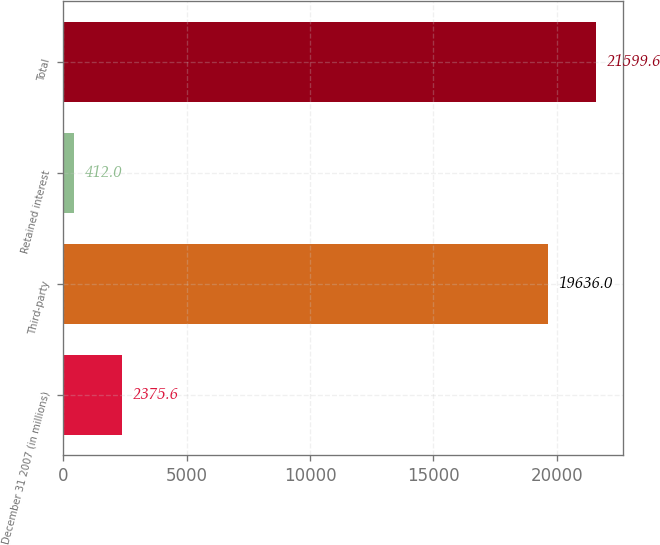Convert chart. <chart><loc_0><loc_0><loc_500><loc_500><bar_chart><fcel>December 31 2007 (in millions)<fcel>Third-party<fcel>Retained interest<fcel>Total<nl><fcel>2375.6<fcel>19636<fcel>412<fcel>21599.6<nl></chart> 